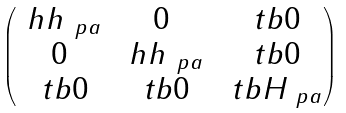Convert formula to latex. <formula><loc_0><loc_0><loc_500><loc_500>\begin{pmatrix} \ h h _ { \ p a } & 0 & \ t b { 0 } \\ 0 & \ h h _ { \ p a } & \ t b { 0 } \\ \ t b { 0 } & \ t b { 0 } & \ t b { H } _ { \ p a } \end{pmatrix}</formula> 